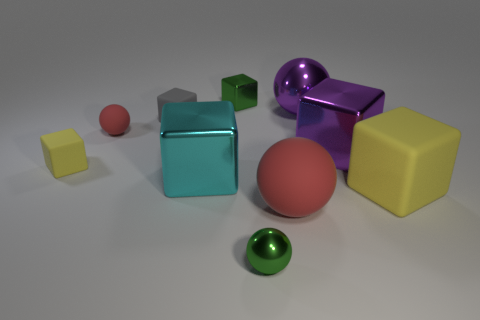Subtract 1 blocks. How many blocks are left? 5 Subtract all purple cubes. How many cubes are left? 5 Subtract all tiny green cubes. How many cubes are left? 5 Subtract all gray cubes. Subtract all red spheres. How many cubes are left? 5 Subtract all cubes. How many objects are left? 4 Subtract 0 cyan balls. How many objects are left? 10 Subtract all big purple objects. Subtract all tiny yellow things. How many objects are left? 7 Add 2 tiny metal things. How many tiny metal things are left? 4 Add 4 large red objects. How many large red objects exist? 5 